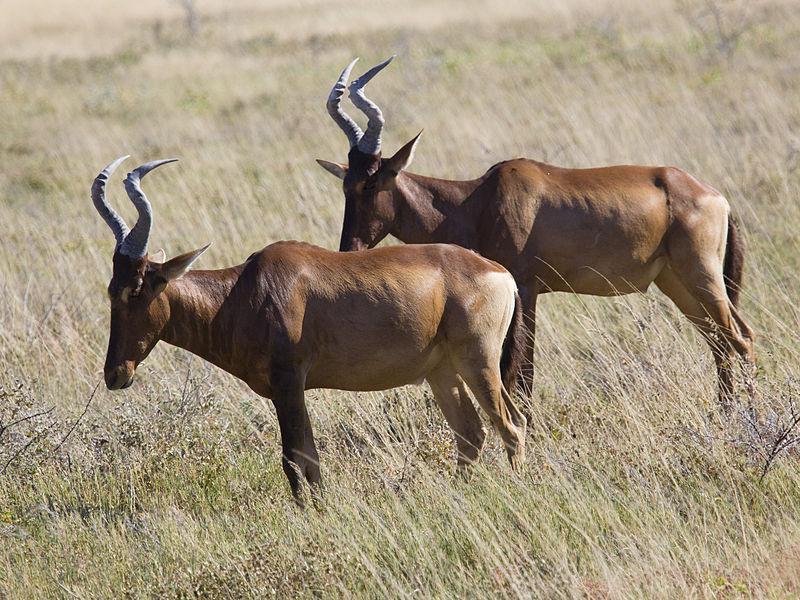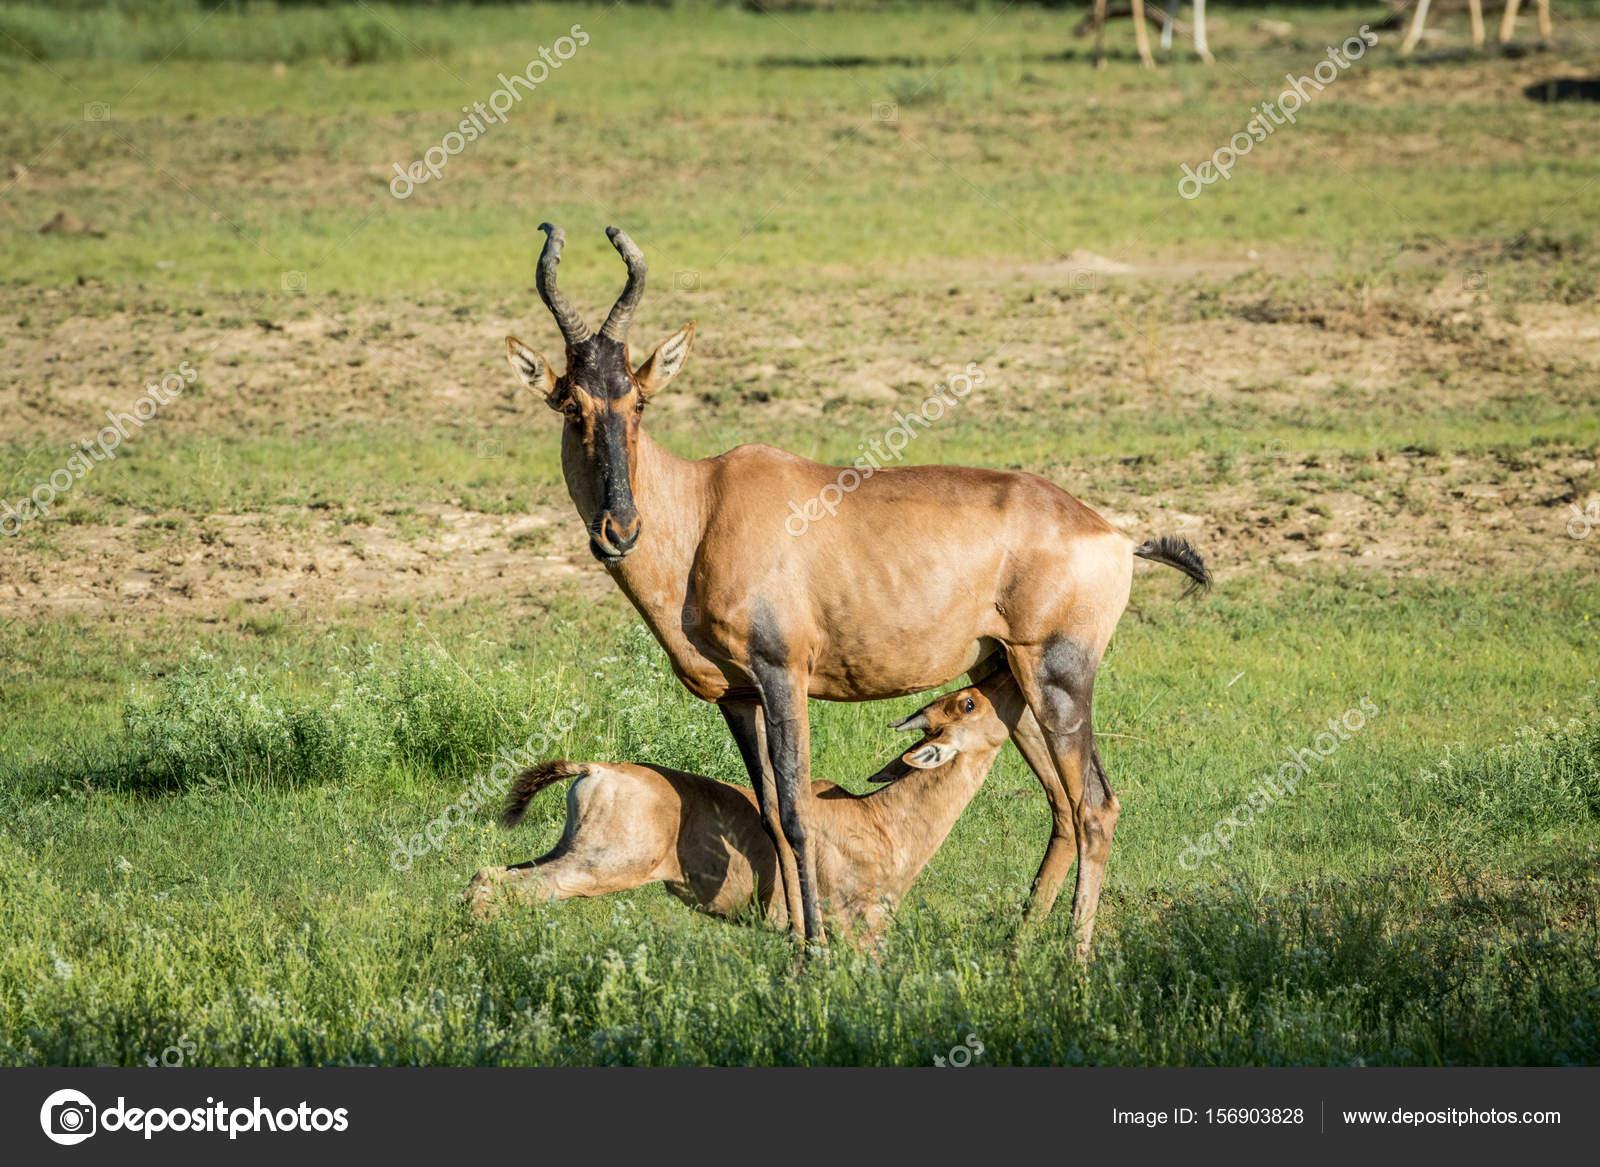The first image is the image on the left, the second image is the image on the right. Analyze the images presented: Is the assertion "There are less than four animals with horns visible." valid? Answer yes or no. No. 